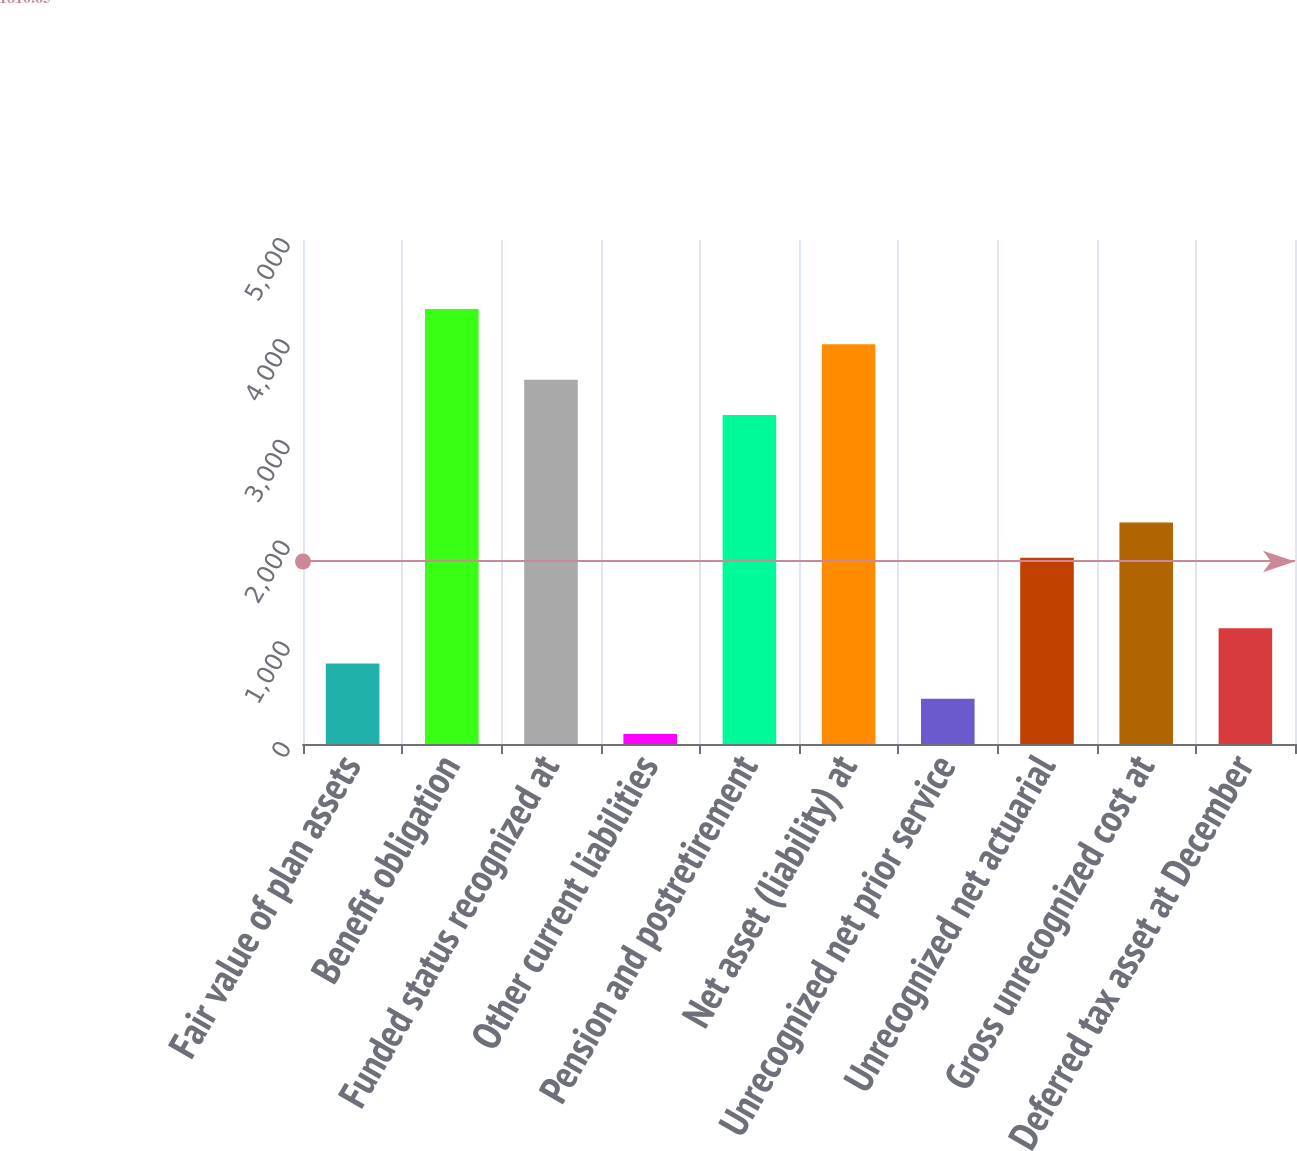Convert chart. <chart><loc_0><loc_0><loc_500><loc_500><bar_chart><fcel>Fair value of plan assets<fcel>Benefit obligation<fcel>Funded status recognized at<fcel>Other current liabilities<fcel>Pension and postretirement<fcel>Net asset (liability) at<fcel>Unrecognized net prior service<fcel>Unrecognized net actuarial<fcel>Gross unrecognized cost at<fcel>Deferred tax asset at December<nl><fcel>798.6<fcel>4314.4<fcel>3614.8<fcel>99<fcel>3265<fcel>3964.6<fcel>448.8<fcel>1848<fcel>2197.8<fcel>1148.4<nl></chart> 